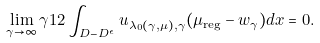Convert formula to latex. <formula><loc_0><loc_0><loc_500><loc_500>\lim _ { \gamma \to \infty } \gamma ^ { } { 1 } 2 \int _ { D - D ^ { \epsilon } } u _ { \lambda _ { 0 } ( \gamma , \mu ) , \gamma } ( \mu _ { \text {reg} } - w _ { \gamma } ) d x = 0 .</formula> 